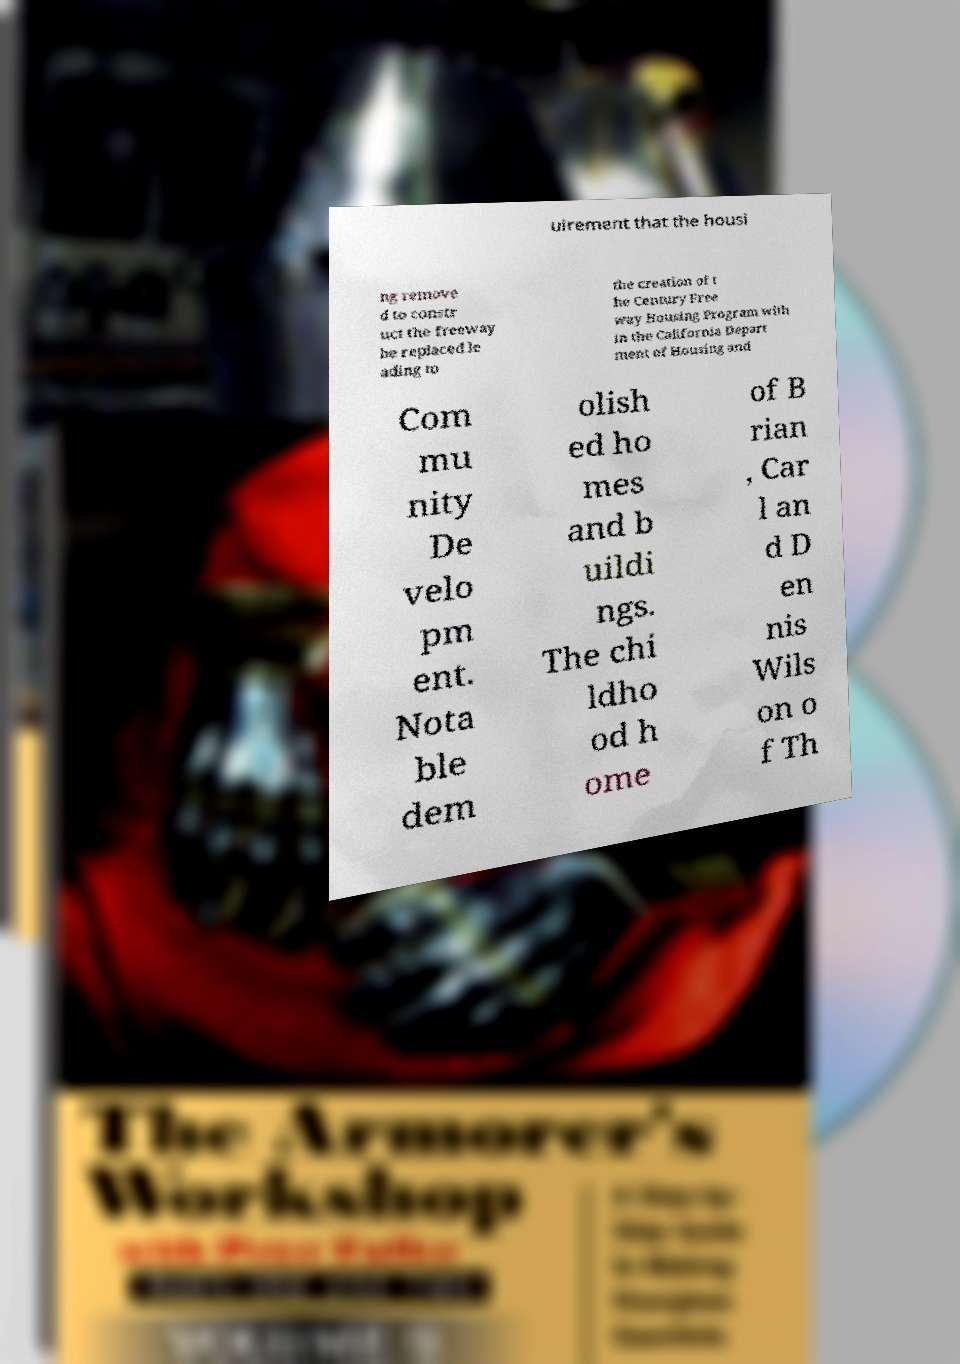Please read and relay the text visible in this image. What does it say? uirement that the housi ng remove d to constr uct the freeway be replaced le ading to the creation of t he Century Free way Housing Program with in the California Depart ment of Housing and Com mu nity De velo pm ent. Nota ble dem olish ed ho mes and b uildi ngs. The chi ldho od h ome of B rian , Car l an d D en nis Wils on o f Th 